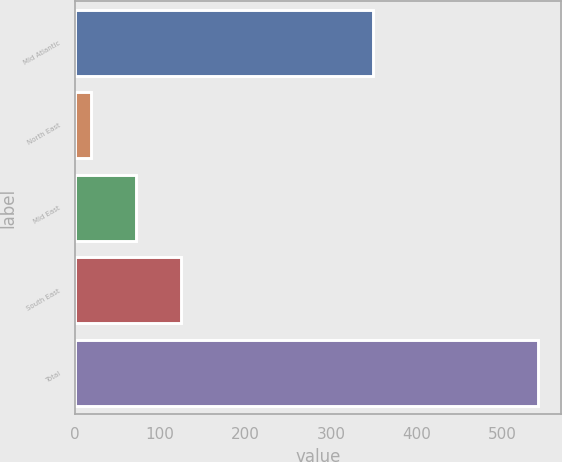Convert chart. <chart><loc_0><loc_0><loc_500><loc_500><bar_chart><fcel>Mid Atlantic<fcel>North East<fcel>Mid East<fcel>South East<fcel>Total<nl><fcel>349<fcel>19<fcel>72<fcel>124.3<fcel>542<nl></chart> 